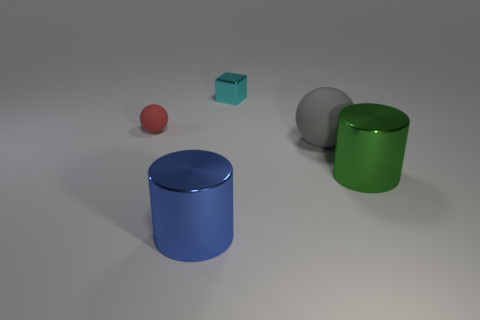What is the sphere left of the large blue object made of?
Offer a terse response. Rubber. Is the number of small blue metal cubes less than the number of big green metal cylinders?
Provide a succinct answer. Yes. Is the shape of the tiny matte object the same as the thing behind the red sphere?
Provide a succinct answer. No. There is a object that is behind the large gray rubber object and on the right side of the small red rubber object; what is its shape?
Provide a short and direct response. Cube. Are there the same number of matte things behind the gray sphere and small shiny cubes on the left side of the small red matte ball?
Ensure brevity in your answer.  No. Is the shape of the small thing in front of the tiny cyan metallic thing the same as  the large rubber thing?
Offer a very short reply. Yes. What number of yellow objects are either large rubber objects or small rubber spheres?
Your answer should be very brief. 0. There is a blue object that is the same shape as the green object; what is it made of?
Your answer should be compact. Metal. The large metal thing that is on the left side of the cyan metallic object has what shape?
Your response must be concise. Cylinder. Is there a small cyan object made of the same material as the green thing?
Your answer should be very brief. Yes. 